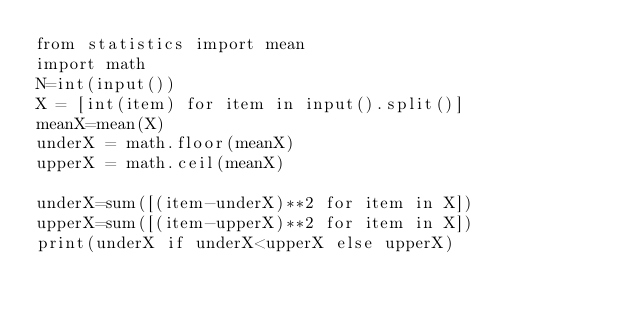Convert code to text. <code><loc_0><loc_0><loc_500><loc_500><_Python_>from statistics import mean
import math
N=int(input())
X = [int(item) for item in input().split()]
meanX=mean(X)
underX = math.floor(meanX)
upperX = math.ceil(meanX)

underX=sum([(item-underX)**2 for item in X])
upperX=sum([(item-upperX)**2 for item in X])
print(underX if underX<upperX else upperX)</code> 